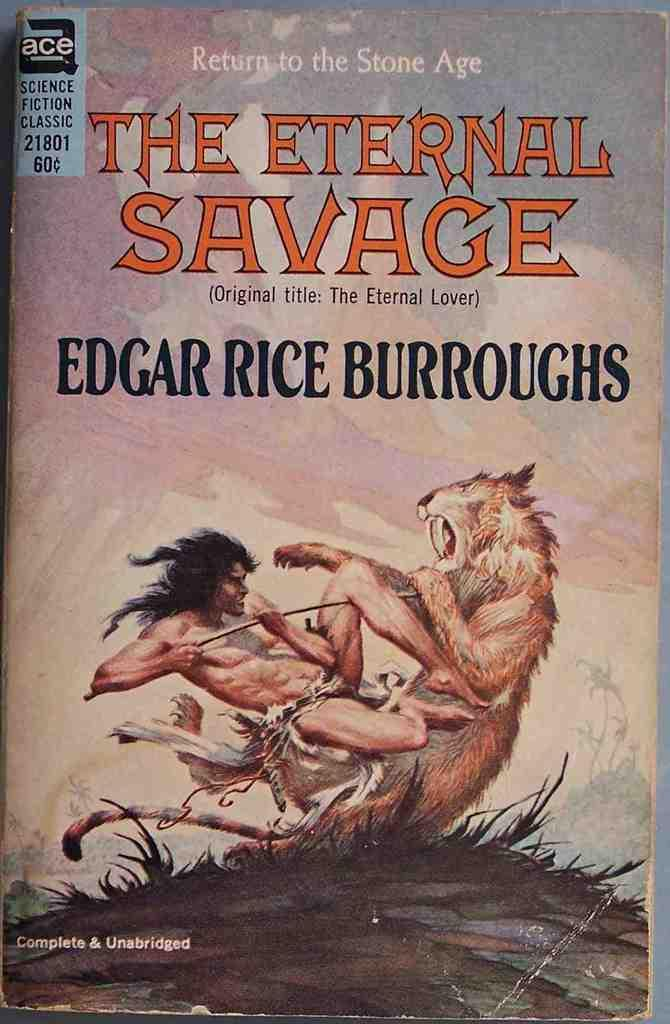<image>
Present a compact description of the photo's key features. Return to the stone age The Eternal Savage book by Edgar Rice Burroughs. 